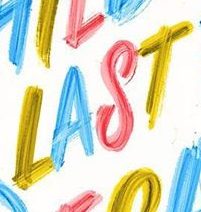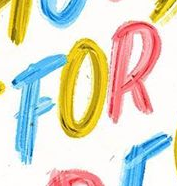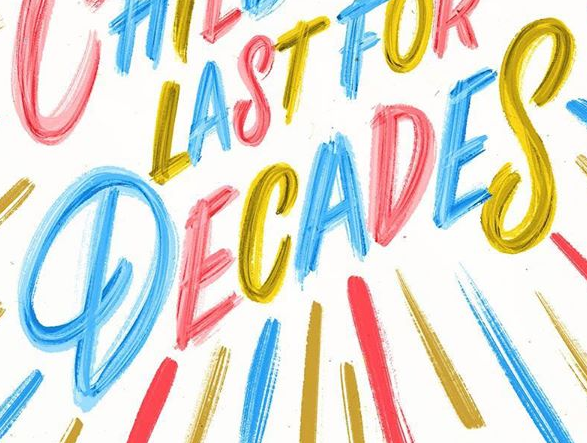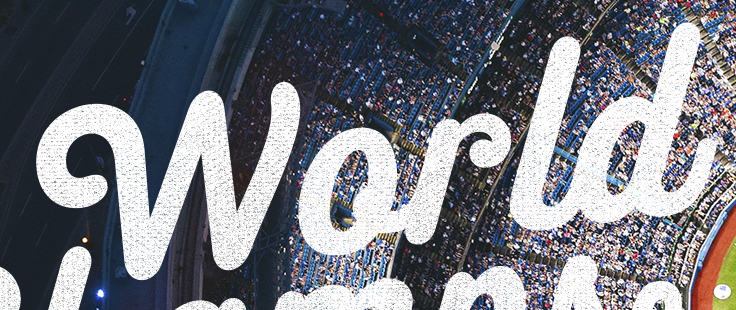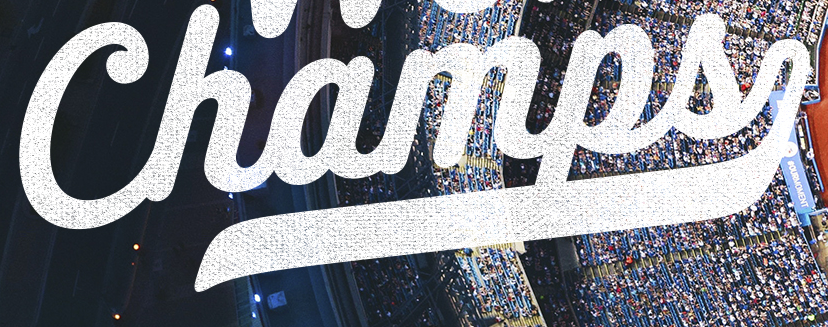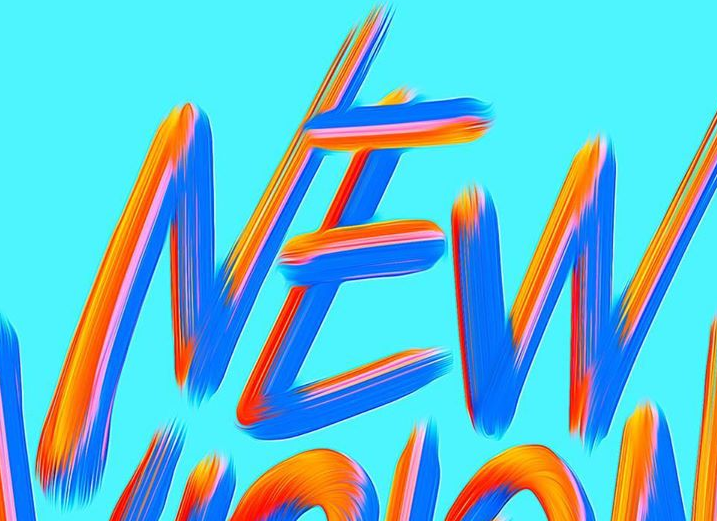Transcribe the words shown in these images in order, separated by a semicolon. LAST; FOR; DECADES; World; Champs; NEW 